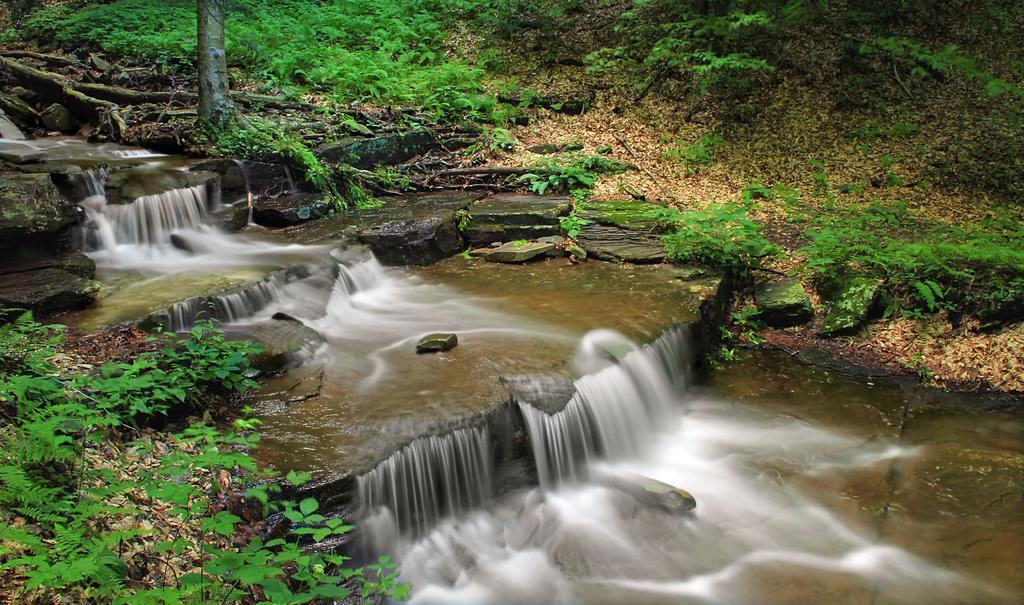How would you summarize this image in a sentence or two? In this picture I can see water flowing and I can see few rocks, plants and trees. 